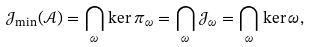<formula> <loc_0><loc_0><loc_500><loc_500>\mathcal { J } _ { \min } ( \mathcal { A } ) = \bigcap _ { \omega } \ker \pi _ { \omega } = \bigcap _ { \omega } \mathcal { J } _ { \omega } = \bigcap _ { \omega } \ker \omega ,</formula> 